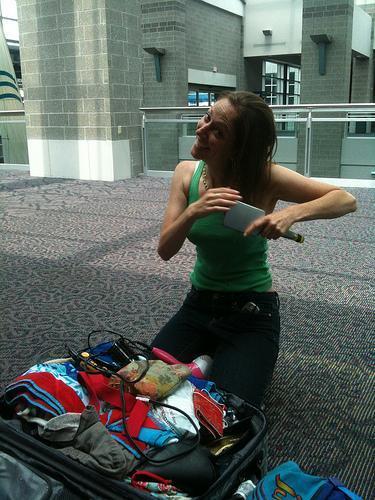How many people are in this picture?
Give a very brief answer. 1. 